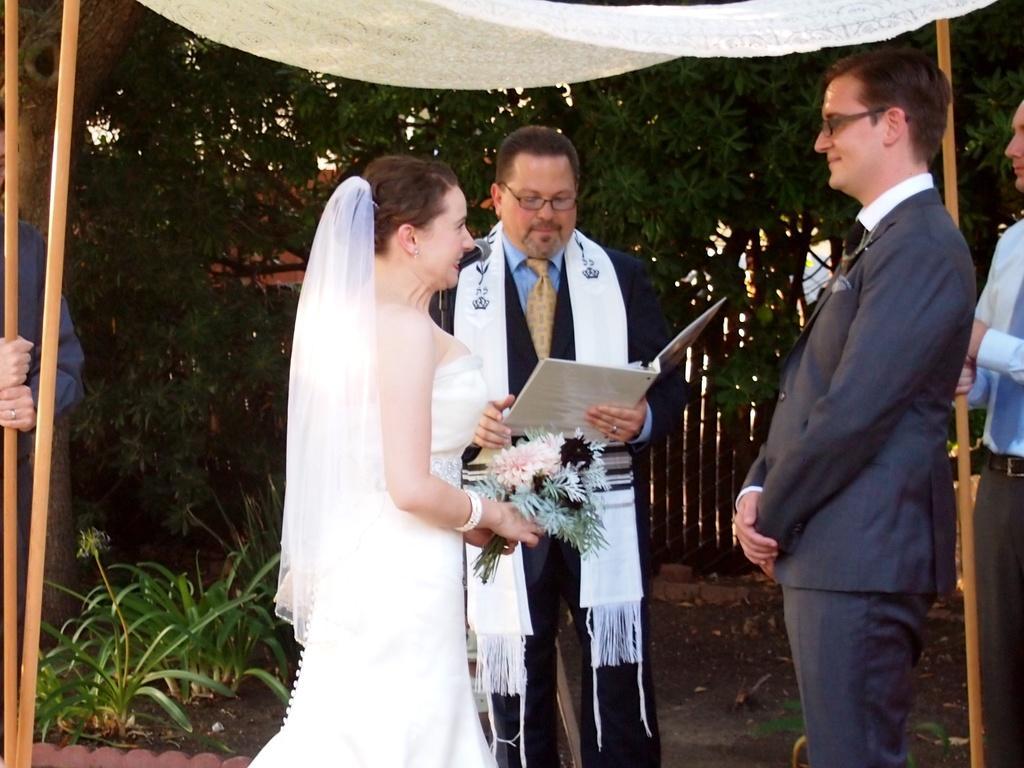In one or two sentences, can you explain what this image depicts? In this image we can see a woman wearing white dress is holding a flower bouquet in her hands, this person wearing a blazer and spectacles is standing here and this person wearing a blazer, cloth and tie is also standing on the ground. On the either side of the image we can see people holding sticks. In the background, we can see small plants, fence and trees. 